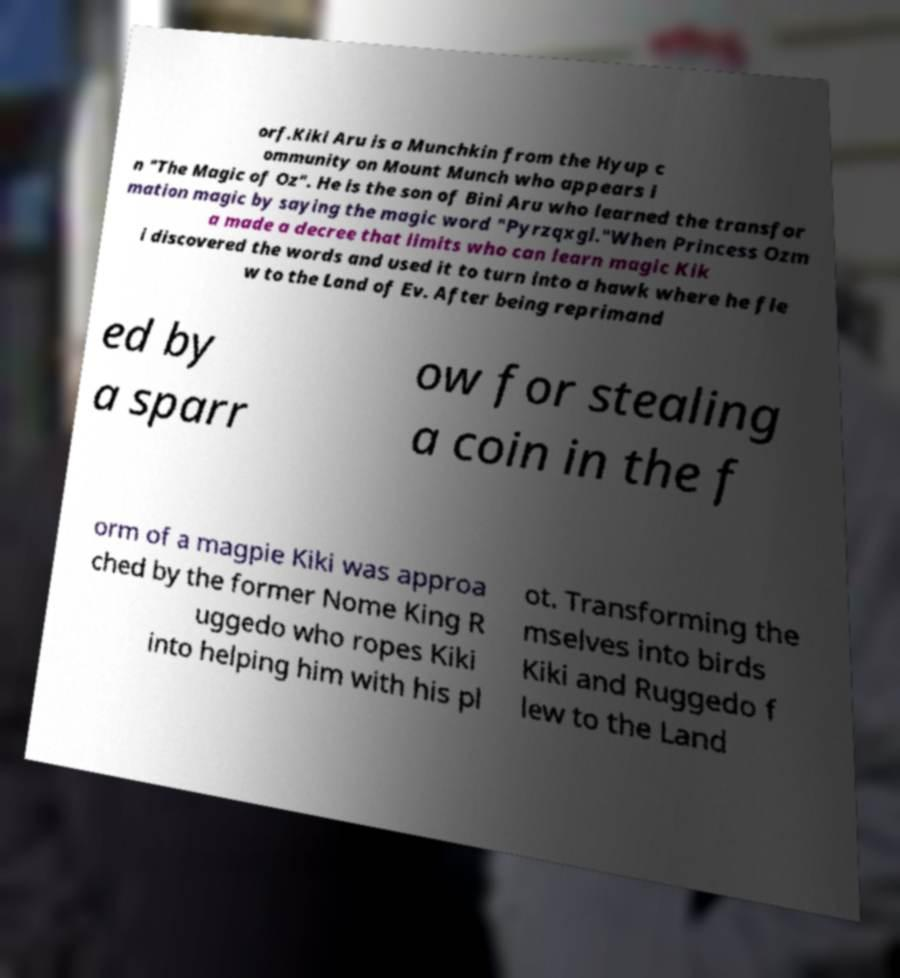Can you read and provide the text displayed in the image?This photo seems to have some interesting text. Can you extract and type it out for me? orf.Kiki Aru is a Munchkin from the Hyup c ommunity on Mount Munch who appears i n "The Magic of Oz". He is the son of Bini Aru who learned the transfor mation magic by saying the magic word "Pyrzqxgl."When Princess Ozm a made a decree that limits who can learn magic Kik i discovered the words and used it to turn into a hawk where he fle w to the Land of Ev. After being reprimand ed by a sparr ow for stealing a coin in the f orm of a magpie Kiki was approa ched by the former Nome King R uggedo who ropes Kiki into helping him with his pl ot. Transforming the mselves into birds Kiki and Ruggedo f lew to the Land 